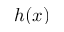Convert formula to latex. <formula><loc_0><loc_0><loc_500><loc_500>h ( x )</formula> 